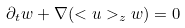<formula> <loc_0><loc_0><loc_500><loc_500>\partial _ { t } w + \nabla ( < u > _ { z } w ) = 0</formula> 